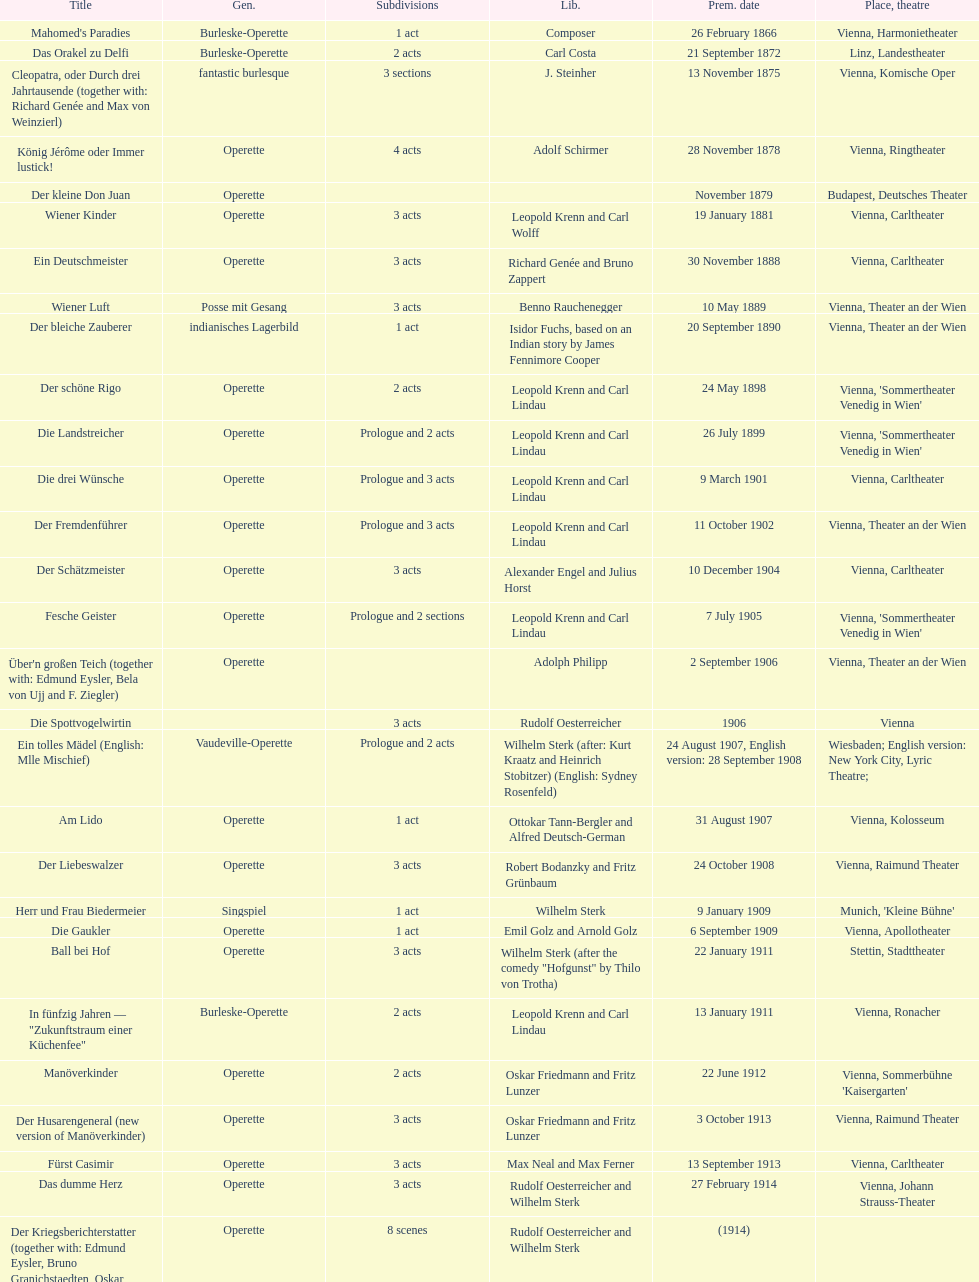All the dates are no later than what year? 1958. 